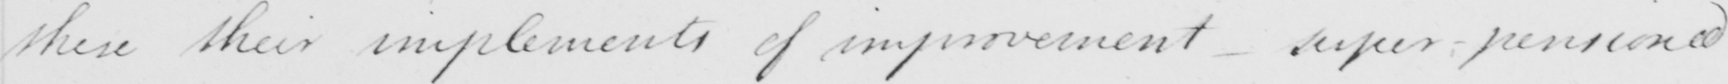Can you tell me what this handwritten text says? these their implements of improvement - super-pensioned 